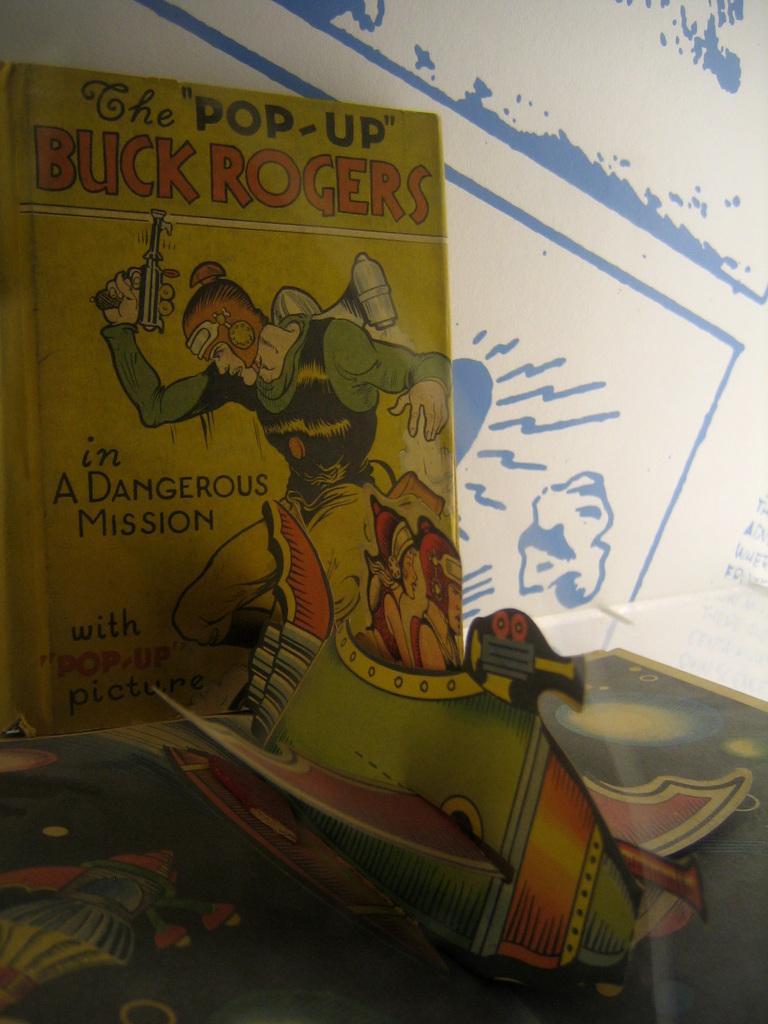What is the name of the main character in this book?
Your response must be concise. Buck rogers. What kind of pictures are in the book?
Provide a short and direct response. Pop-up. 